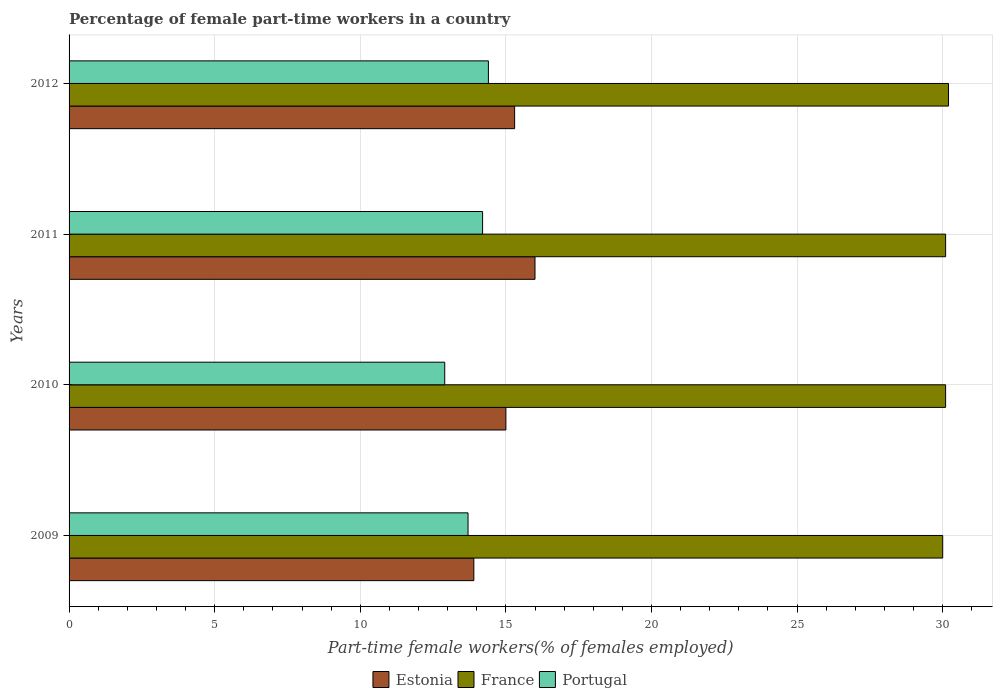How many groups of bars are there?
Your response must be concise. 4. In how many cases, is the number of bars for a given year not equal to the number of legend labels?
Give a very brief answer. 0. What is the percentage of female part-time workers in France in 2012?
Make the answer very short. 30.2. Across all years, what is the minimum percentage of female part-time workers in France?
Ensure brevity in your answer.  30. In which year was the percentage of female part-time workers in Portugal maximum?
Offer a terse response. 2012. In which year was the percentage of female part-time workers in Estonia minimum?
Your answer should be compact. 2009. What is the total percentage of female part-time workers in Portugal in the graph?
Provide a short and direct response. 55.2. What is the difference between the percentage of female part-time workers in Portugal in 2010 and that in 2012?
Your response must be concise. -1.5. What is the difference between the percentage of female part-time workers in France in 2009 and the percentage of female part-time workers in Estonia in 2011?
Give a very brief answer. 14. What is the average percentage of female part-time workers in Estonia per year?
Give a very brief answer. 15.05. In the year 2011, what is the difference between the percentage of female part-time workers in France and percentage of female part-time workers in Estonia?
Offer a terse response. 14.1. What is the ratio of the percentage of female part-time workers in Estonia in 2009 to that in 2011?
Ensure brevity in your answer.  0.87. Is the percentage of female part-time workers in France in 2009 less than that in 2011?
Offer a very short reply. Yes. Is the difference between the percentage of female part-time workers in France in 2009 and 2010 greater than the difference between the percentage of female part-time workers in Estonia in 2009 and 2010?
Offer a terse response. Yes. What is the difference between the highest and the second highest percentage of female part-time workers in Estonia?
Provide a short and direct response. 0.7. Is it the case that in every year, the sum of the percentage of female part-time workers in Estonia and percentage of female part-time workers in France is greater than the percentage of female part-time workers in Portugal?
Make the answer very short. Yes. How many bars are there?
Offer a very short reply. 12. Where does the legend appear in the graph?
Provide a succinct answer. Bottom center. How many legend labels are there?
Ensure brevity in your answer.  3. How are the legend labels stacked?
Offer a very short reply. Horizontal. What is the title of the graph?
Your answer should be very brief. Percentage of female part-time workers in a country. What is the label or title of the X-axis?
Your response must be concise. Part-time female workers(% of females employed). What is the Part-time female workers(% of females employed) of Estonia in 2009?
Your response must be concise. 13.9. What is the Part-time female workers(% of females employed) of France in 2009?
Provide a short and direct response. 30. What is the Part-time female workers(% of females employed) in Portugal in 2009?
Your answer should be compact. 13.7. What is the Part-time female workers(% of females employed) in France in 2010?
Keep it short and to the point. 30.1. What is the Part-time female workers(% of females employed) of Portugal in 2010?
Your response must be concise. 12.9. What is the Part-time female workers(% of females employed) of France in 2011?
Provide a short and direct response. 30.1. What is the Part-time female workers(% of females employed) of Portugal in 2011?
Your answer should be compact. 14.2. What is the Part-time female workers(% of females employed) in Estonia in 2012?
Your answer should be compact. 15.3. What is the Part-time female workers(% of females employed) in France in 2012?
Ensure brevity in your answer.  30.2. What is the Part-time female workers(% of females employed) of Portugal in 2012?
Make the answer very short. 14.4. Across all years, what is the maximum Part-time female workers(% of females employed) of Estonia?
Make the answer very short. 16. Across all years, what is the maximum Part-time female workers(% of females employed) of France?
Provide a succinct answer. 30.2. Across all years, what is the maximum Part-time female workers(% of females employed) of Portugal?
Offer a terse response. 14.4. Across all years, what is the minimum Part-time female workers(% of females employed) in Estonia?
Ensure brevity in your answer.  13.9. Across all years, what is the minimum Part-time female workers(% of females employed) in France?
Ensure brevity in your answer.  30. Across all years, what is the minimum Part-time female workers(% of females employed) of Portugal?
Provide a short and direct response. 12.9. What is the total Part-time female workers(% of females employed) of Estonia in the graph?
Make the answer very short. 60.2. What is the total Part-time female workers(% of females employed) in France in the graph?
Offer a terse response. 120.4. What is the total Part-time female workers(% of females employed) of Portugal in the graph?
Your response must be concise. 55.2. What is the difference between the Part-time female workers(% of females employed) of Estonia in 2009 and that in 2010?
Provide a succinct answer. -1.1. What is the difference between the Part-time female workers(% of females employed) of France in 2009 and that in 2010?
Your response must be concise. -0.1. What is the difference between the Part-time female workers(% of females employed) in Portugal in 2009 and that in 2010?
Make the answer very short. 0.8. What is the difference between the Part-time female workers(% of females employed) in France in 2009 and that in 2012?
Your response must be concise. -0.2. What is the difference between the Part-time female workers(% of females employed) of Portugal in 2009 and that in 2012?
Your answer should be very brief. -0.7. What is the difference between the Part-time female workers(% of females employed) of Portugal in 2010 and that in 2011?
Keep it short and to the point. -1.3. What is the difference between the Part-time female workers(% of females employed) of Estonia in 2010 and that in 2012?
Make the answer very short. -0.3. What is the difference between the Part-time female workers(% of females employed) of France in 2010 and that in 2012?
Offer a very short reply. -0.1. What is the difference between the Part-time female workers(% of females employed) of Portugal in 2010 and that in 2012?
Your answer should be compact. -1.5. What is the difference between the Part-time female workers(% of females employed) of France in 2011 and that in 2012?
Provide a succinct answer. -0.1. What is the difference between the Part-time female workers(% of females employed) of Portugal in 2011 and that in 2012?
Your answer should be very brief. -0.2. What is the difference between the Part-time female workers(% of females employed) in Estonia in 2009 and the Part-time female workers(% of females employed) in France in 2010?
Provide a succinct answer. -16.2. What is the difference between the Part-time female workers(% of females employed) of Estonia in 2009 and the Part-time female workers(% of females employed) of Portugal in 2010?
Your response must be concise. 1. What is the difference between the Part-time female workers(% of females employed) of France in 2009 and the Part-time female workers(% of females employed) of Portugal in 2010?
Your response must be concise. 17.1. What is the difference between the Part-time female workers(% of females employed) in Estonia in 2009 and the Part-time female workers(% of females employed) in France in 2011?
Offer a terse response. -16.2. What is the difference between the Part-time female workers(% of females employed) of France in 2009 and the Part-time female workers(% of females employed) of Portugal in 2011?
Your answer should be compact. 15.8. What is the difference between the Part-time female workers(% of females employed) of Estonia in 2009 and the Part-time female workers(% of females employed) of France in 2012?
Keep it short and to the point. -16.3. What is the difference between the Part-time female workers(% of females employed) of Estonia in 2009 and the Part-time female workers(% of females employed) of Portugal in 2012?
Your answer should be very brief. -0.5. What is the difference between the Part-time female workers(% of females employed) of France in 2009 and the Part-time female workers(% of females employed) of Portugal in 2012?
Offer a very short reply. 15.6. What is the difference between the Part-time female workers(% of females employed) of Estonia in 2010 and the Part-time female workers(% of females employed) of France in 2011?
Give a very brief answer. -15.1. What is the difference between the Part-time female workers(% of females employed) of Estonia in 2010 and the Part-time female workers(% of females employed) of France in 2012?
Your response must be concise. -15.2. What is the difference between the Part-time female workers(% of females employed) in Estonia in 2010 and the Part-time female workers(% of females employed) in Portugal in 2012?
Offer a very short reply. 0.6. What is the difference between the Part-time female workers(% of females employed) in Estonia in 2011 and the Part-time female workers(% of females employed) in France in 2012?
Offer a very short reply. -14.2. What is the difference between the Part-time female workers(% of females employed) of Estonia in 2011 and the Part-time female workers(% of females employed) of Portugal in 2012?
Offer a very short reply. 1.6. What is the average Part-time female workers(% of females employed) of Estonia per year?
Your response must be concise. 15.05. What is the average Part-time female workers(% of females employed) of France per year?
Ensure brevity in your answer.  30.1. What is the average Part-time female workers(% of females employed) of Portugal per year?
Offer a very short reply. 13.8. In the year 2009, what is the difference between the Part-time female workers(% of females employed) of Estonia and Part-time female workers(% of females employed) of France?
Offer a very short reply. -16.1. In the year 2009, what is the difference between the Part-time female workers(% of females employed) of Estonia and Part-time female workers(% of females employed) of Portugal?
Give a very brief answer. 0.2. In the year 2010, what is the difference between the Part-time female workers(% of females employed) of Estonia and Part-time female workers(% of females employed) of France?
Ensure brevity in your answer.  -15.1. In the year 2010, what is the difference between the Part-time female workers(% of females employed) in Estonia and Part-time female workers(% of females employed) in Portugal?
Give a very brief answer. 2.1. In the year 2010, what is the difference between the Part-time female workers(% of females employed) in France and Part-time female workers(% of females employed) in Portugal?
Give a very brief answer. 17.2. In the year 2011, what is the difference between the Part-time female workers(% of females employed) of Estonia and Part-time female workers(% of females employed) of France?
Your response must be concise. -14.1. In the year 2012, what is the difference between the Part-time female workers(% of females employed) in Estonia and Part-time female workers(% of females employed) in France?
Your answer should be very brief. -14.9. What is the ratio of the Part-time female workers(% of females employed) in Estonia in 2009 to that in 2010?
Make the answer very short. 0.93. What is the ratio of the Part-time female workers(% of females employed) of France in 2009 to that in 2010?
Keep it short and to the point. 1. What is the ratio of the Part-time female workers(% of females employed) in Portugal in 2009 to that in 2010?
Provide a succinct answer. 1.06. What is the ratio of the Part-time female workers(% of females employed) of Estonia in 2009 to that in 2011?
Keep it short and to the point. 0.87. What is the ratio of the Part-time female workers(% of females employed) in Portugal in 2009 to that in 2011?
Make the answer very short. 0.96. What is the ratio of the Part-time female workers(% of females employed) in Estonia in 2009 to that in 2012?
Ensure brevity in your answer.  0.91. What is the ratio of the Part-time female workers(% of females employed) of Portugal in 2009 to that in 2012?
Give a very brief answer. 0.95. What is the ratio of the Part-time female workers(% of females employed) in France in 2010 to that in 2011?
Provide a succinct answer. 1. What is the ratio of the Part-time female workers(% of females employed) in Portugal in 2010 to that in 2011?
Keep it short and to the point. 0.91. What is the ratio of the Part-time female workers(% of females employed) of Estonia in 2010 to that in 2012?
Offer a very short reply. 0.98. What is the ratio of the Part-time female workers(% of females employed) in Portugal in 2010 to that in 2012?
Ensure brevity in your answer.  0.9. What is the ratio of the Part-time female workers(% of females employed) of Estonia in 2011 to that in 2012?
Provide a short and direct response. 1.05. What is the ratio of the Part-time female workers(% of females employed) of Portugal in 2011 to that in 2012?
Give a very brief answer. 0.99. What is the difference between the highest and the second highest Part-time female workers(% of females employed) in Estonia?
Your response must be concise. 0.7. What is the difference between the highest and the lowest Part-time female workers(% of females employed) of Estonia?
Offer a terse response. 2.1. What is the difference between the highest and the lowest Part-time female workers(% of females employed) in France?
Offer a very short reply. 0.2. What is the difference between the highest and the lowest Part-time female workers(% of females employed) in Portugal?
Your response must be concise. 1.5. 